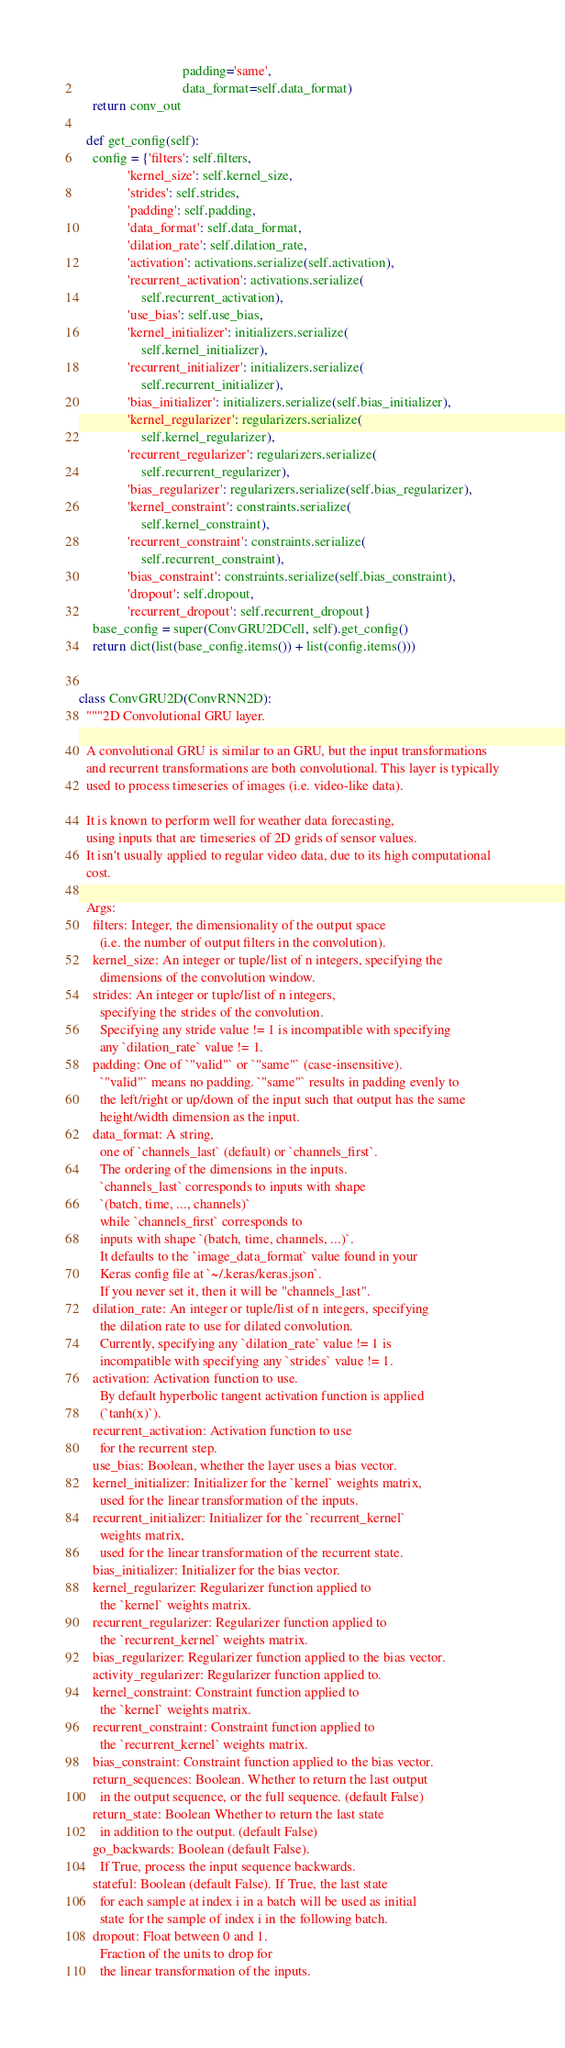<code> <loc_0><loc_0><loc_500><loc_500><_Python_>                              padding='same',
                              data_format=self.data_format)
    return conv_out

  def get_config(self):
    config = {'filters': self.filters,
              'kernel_size': self.kernel_size,
              'strides': self.strides,
              'padding': self.padding,
              'data_format': self.data_format,
              'dilation_rate': self.dilation_rate,
              'activation': activations.serialize(self.activation),
              'recurrent_activation': activations.serialize(
                  self.recurrent_activation),
              'use_bias': self.use_bias,
              'kernel_initializer': initializers.serialize(
                  self.kernel_initializer),
              'recurrent_initializer': initializers.serialize(
                  self.recurrent_initializer),
              'bias_initializer': initializers.serialize(self.bias_initializer),
              'kernel_regularizer': regularizers.serialize(
                  self.kernel_regularizer),
              'recurrent_regularizer': regularizers.serialize(
                  self.recurrent_regularizer),
              'bias_regularizer': regularizers.serialize(self.bias_regularizer),
              'kernel_constraint': constraints.serialize(
                  self.kernel_constraint),
              'recurrent_constraint': constraints.serialize(
                  self.recurrent_constraint),
              'bias_constraint': constraints.serialize(self.bias_constraint),
              'dropout': self.dropout,
              'recurrent_dropout': self.recurrent_dropout}
    base_config = super(ConvGRU2DCell, self).get_config()
    return dict(list(base_config.items()) + list(config.items()))


class ConvGRU2D(ConvRNN2D):
  """2D Convolutional GRU layer.

  A convolutional GRU is similar to an GRU, but the input transformations
  and recurrent transformations are both convolutional. This layer is typically
  used to process timeseries of images (i.e. video-like data).

  It is known to perform well for weather data forecasting,
  using inputs that are timeseries of 2D grids of sensor values.
  It isn't usually applied to regular video data, due to its high computational
  cost.

  Args:
    filters: Integer, the dimensionality of the output space
      (i.e. the number of output filters in the convolution).
    kernel_size: An integer or tuple/list of n integers, specifying the
      dimensions of the convolution window.
    strides: An integer or tuple/list of n integers,
      specifying the strides of the convolution.
      Specifying any stride value != 1 is incompatible with specifying
      any `dilation_rate` value != 1.
    padding: One of `"valid"` or `"same"` (case-insensitive).
      `"valid"` means no padding. `"same"` results in padding evenly to
      the left/right or up/down of the input such that output has the same
      height/width dimension as the input.
    data_format: A string,
      one of `channels_last` (default) or `channels_first`.
      The ordering of the dimensions in the inputs.
      `channels_last` corresponds to inputs with shape
      `(batch, time, ..., channels)`
      while `channels_first` corresponds to
      inputs with shape `(batch, time, channels, ...)`.
      It defaults to the `image_data_format` value found in your
      Keras config file at `~/.keras/keras.json`.
      If you never set it, then it will be "channels_last".
    dilation_rate: An integer or tuple/list of n integers, specifying
      the dilation rate to use for dilated convolution.
      Currently, specifying any `dilation_rate` value != 1 is
      incompatible with specifying any `strides` value != 1.
    activation: Activation function to use.
      By default hyperbolic tangent activation function is applied
      (`tanh(x)`).
    recurrent_activation: Activation function to use
      for the recurrent step.
    use_bias: Boolean, whether the layer uses a bias vector.
    kernel_initializer: Initializer for the `kernel` weights matrix,
      used for the linear transformation of the inputs.
    recurrent_initializer: Initializer for the `recurrent_kernel`
      weights matrix,
      used for the linear transformation of the recurrent state.
    bias_initializer: Initializer for the bias vector.
    kernel_regularizer: Regularizer function applied to
      the `kernel` weights matrix.
    recurrent_regularizer: Regularizer function applied to
      the `recurrent_kernel` weights matrix.
    bias_regularizer: Regularizer function applied to the bias vector.
    activity_regularizer: Regularizer function applied to.
    kernel_constraint: Constraint function applied to
      the `kernel` weights matrix.
    recurrent_constraint: Constraint function applied to
      the `recurrent_kernel` weights matrix.
    bias_constraint: Constraint function applied to the bias vector.
    return_sequences: Boolean. Whether to return the last output
      in the output sequence, or the full sequence. (default False)
    return_state: Boolean Whether to return the last state
      in addition to the output. (default False)
    go_backwards: Boolean (default False).
      If True, process the input sequence backwards.
    stateful: Boolean (default False). If True, the last state
      for each sample at index i in a batch will be used as initial
      state for the sample of index i in the following batch.
    dropout: Float between 0 and 1.
      Fraction of the units to drop for
      the linear transformation of the inputs.</code> 